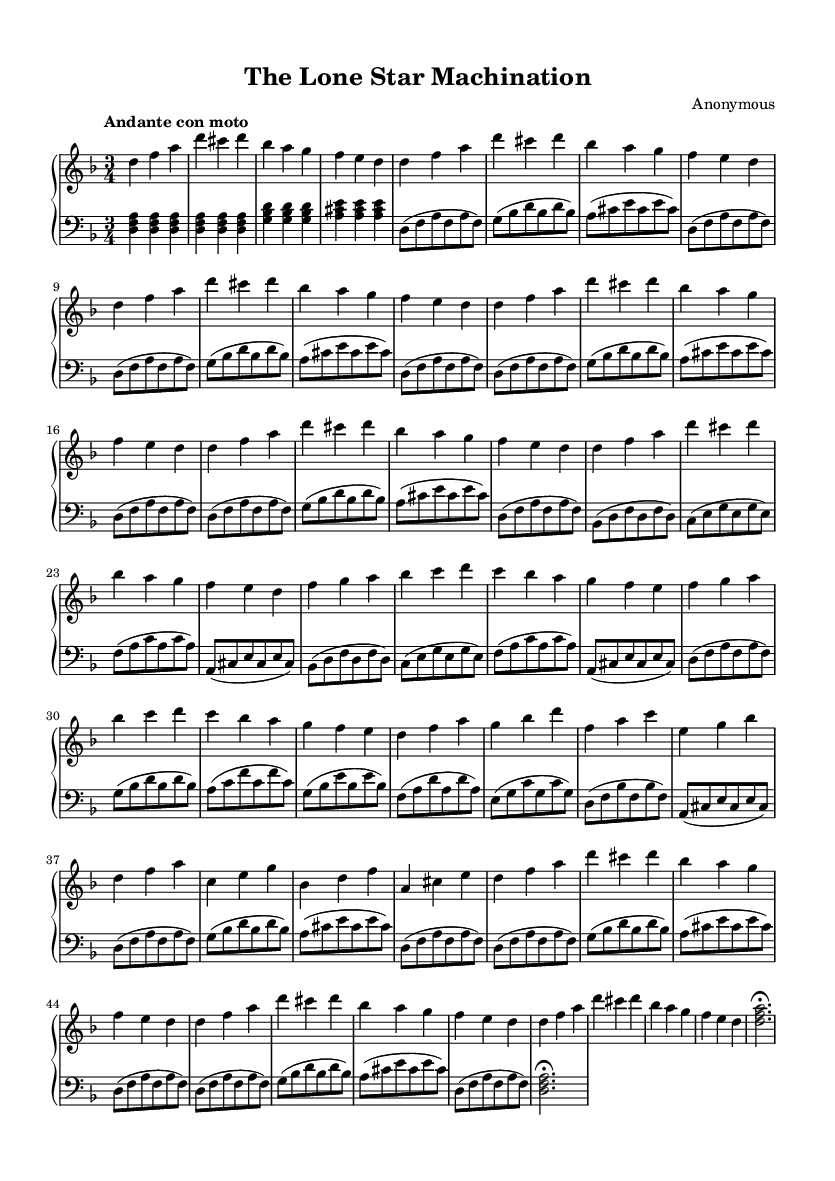What is the key signature of this music? The key signature is indicated at the beginning of the music, showing two flats (B flat and E flat), which indicates the key of D minor.
Answer: D minor What is the time signature of this piece? The time signature is located at the beginning of the sheet music and is denoted as 3/4, indicating three beats per measure.
Answer: 3/4 What is the tempo marking for this composition? The tempo marking is found at the start of the music and is stated as "Andante con moto," indicating a moderately slow tempo with some movement.
Answer: Andante con moto How many times is Theme A repeated? By examining the music, Theme A is explicitly noted to repeat two times in the structure, as indicated by the repeat sign.
Answer: 2 What is the mood likely conveyed by the overall piece? Analyzing the D minor key along with the tempo and rhythmic structure suggests a somewhat somber yet flowy character, typical of Romantic pieces.
Answer: Somber What type of cadences are present in the coda section? The harmonic endings in the coda involve conclusive full chords that typically signify a perfect cadence, creating a satisfying conclusion.
Answer: Perfect cadence 